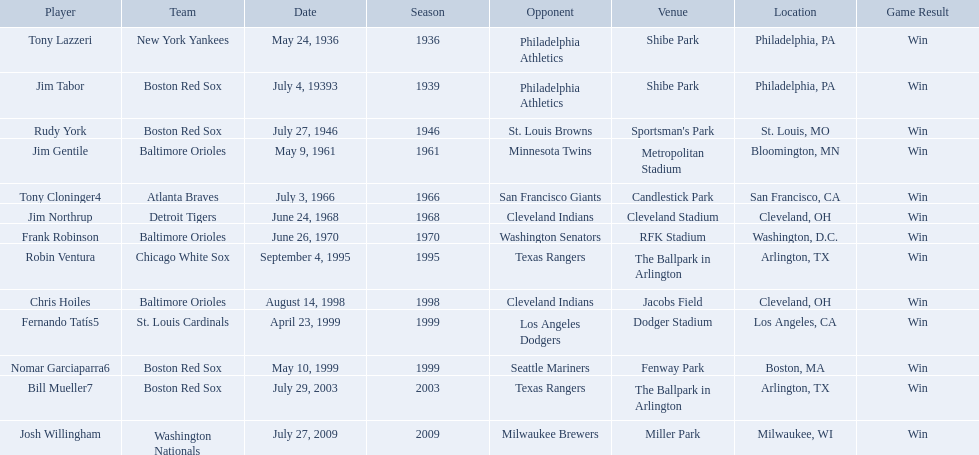What venue did detroit play cleveland in? Cleveland Stadium. Who was the player? Jim Northrup. What date did they play? June 24, 1968. Write the full table. {'header': ['Player', 'Team', 'Date', 'Season', 'Opponent', 'Venue', 'Location', 'Game Result'], 'rows': [['Tony Lazzeri', 'New York Yankees', 'May 24, 1936', '1936', 'Philadelphia Athletics', 'Shibe Park', 'Philadelphia, PA', 'Win'], ['Jim Tabor', 'Boston Red Sox', 'July 4, 19393', '1939', 'Philadelphia Athletics', 'Shibe Park', 'Philadelphia, PA', 'Win'], ['Rudy York', 'Boston Red Sox', 'July 27, 1946', '1946', 'St. Louis Browns', "Sportsman's Park", 'St. Louis, MO', 'Win'], ['Jim Gentile', 'Baltimore Orioles', 'May 9, 1961', '1961', 'Minnesota Twins', 'Metropolitan Stadium', 'Bloomington, MN', 'Win'], ['Tony Cloninger4', 'Atlanta Braves', 'July 3, 1966', '1966', 'San Francisco Giants', 'Candlestick Park', 'San Francisco, CA', 'Win'], ['Jim Northrup', 'Detroit Tigers', 'June 24, 1968', '1968', 'Cleveland Indians', 'Cleveland Stadium', 'Cleveland, OH', 'Win'], ['Frank Robinson', 'Baltimore Orioles', 'June 26, 1970', '1970', 'Washington Senators', 'RFK Stadium', 'Washington, D.C.', 'Win'], ['Robin Ventura', 'Chicago White Sox', 'September 4, 1995', '1995', 'Texas Rangers', 'The Ballpark in Arlington', 'Arlington, TX', 'Win'], ['Chris Hoiles', 'Baltimore Orioles', 'August 14, 1998', '1998', 'Cleveland Indians', 'Jacobs Field', 'Cleveland, OH', 'Win'], ['Fernando Tatís5', 'St. Louis Cardinals', 'April 23, 1999', '1999', 'Los Angeles Dodgers', 'Dodger Stadium', 'Los Angeles, CA', 'Win'], ['Nomar Garciaparra6', 'Boston Red Sox', 'May 10, 1999', '1999', 'Seattle Mariners', 'Fenway Park', 'Boston, MA', 'Win'], ['Bill Mueller7', 'Boston Red Sox', 'July 29, 2003', '2003', 'Texas Rangers', 'The Ballpark in Arlington', 'Arlington, TX', 'Win'], ['Josh Willingham', 'Washington Nationals', 'July 27, 2009', '2009', 'Milwaukee Brewers', 'Miller Park', 'Milwaukee, WI', 'Win']]} What were the dates of each game? May 24, 1936, July 4, 19393, July 27, 1946, May 9, 1961, July 3, 1966, June 24, 1968, June 26, 1970, September 4, 1995, August 14, 1998, April 23, 1999, May 10, 1999, July 29, 2003, July 27, 2009. Who were all of the teams? New York Yankees, Boston Red Sox, Boston Red Sox, Baltimore Orioles, Atlanta Braves, Detroit Tigers, Baltimore Orioles, Chicago White Sox, Baltimore Orioles, St. Louis Cardinals, Boston Red Sox, Boston Red Sox, Washington Nationals. What about their opponents? Philadelphia Athletics, Philadelphia Athletics, St. Louis Browns, Minnesota Twins, San Francisco Giants, Cleveland Indians, Washington Senators, Texas Rangers, Cleveland Indians, Los Angeles Dodgers, Seattle Mariners, Texas Rangers, Milwaukee Brewers. And on which date did the detroit tigers play against the cleveland indians? June 24, 1968. Who are all the opponents? Philadelphia Athletics, Philadelphia Athletics, St. Louis Browns, Minnesota Twins, San Francisco Giants, Cleveland Indians, Washington Senators, Texas Rangers, Cleveland Indians, Los Angeles Dodgers, Seattle Mariners, Texas Rangers, Milwaukee Brewers. What teams played on july 27, 1946? Boston Red Sox, July 27, 1946, St. Louis Browns. Who was the opponent in this game? St. Louis Browns. What are the names of all the players? Tony Lazzeri, Jim Tabor, Rudy York, Jim Gentile, Tony Cloninger4, Jim Northrup, Frank Robinson, Robin Ventura, Chris Hoiles, Fernando Tatís5, Nomar Garciaparra6, Bill Mueller7, Josh Willingham. What are the names of all the teams holding home run records? New York Yankees, Boston Red Sox, Baltimore Orioles, Atlanta Braves, Detroit Tigers, Chicago White Sox, St. Louis Cardinals, Washington Nationals. Which player played for the new york yankees? Tony Lazzeri. 